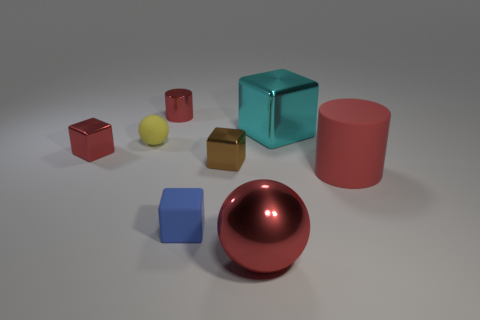Subtract 2 cubes. How many cubes are left? 2 Subtract all red cubes. How many cubes are left? 3 Add 2 small gray metallic spheres. How many objects exist? 10 Subtract all yellow cubes. Subtract all brown spheres. How many cubes are left? 4 Subtract all cylinders. How many objects are left? 6 Add 2 large shiny spheres. How many large shiny spheres are left? 3 Add 5 big brown metal blocks. How many big brown metal blocks exist? 5 Subtract 0 brown cylinders. How many objects are left? 8 Subtract all large spheres. Subtract all brown cubes. How many objects are left? 6 